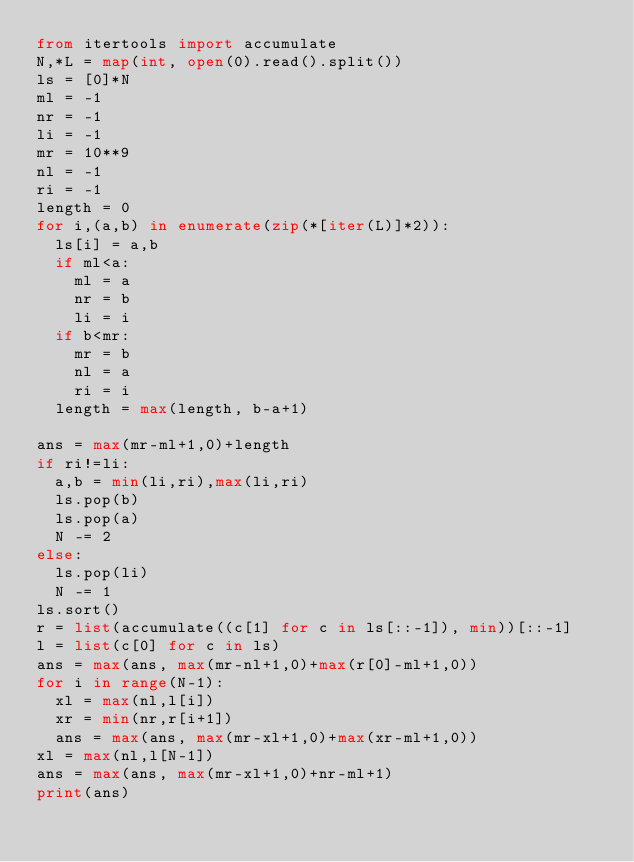Convert code to text. <code><loc_0><loc_0><loc_500><loc_500><_Python_>from itertools import accumulate
N,*L = map(int, open(0).read().split())
ls = [0]*N
ml = -1
nr = -1
li = -1
mr = 10**9
nl = -1
ri = -1
length = 0
for i,(a,b) in enumerate(zip(*[iter(L)]*2)):
  ls[i] = a,b
  if ml<a:
    ml = a
    nr = b
    li = i
  if b<mr:
    mr = b
    nl = a
    ri = i
  length = max(length, b-a+1)

ans = max(mr-ml+1,0)+length
if ri!=li:
  a,b = min(li,ri),max(li,ri)
  ls.pop(b)
  ls.pop(a)
  N -= 2
else:
  ls.pop(li)
  N -= 1
ls.sort()
r = list(accumulate((c[1] for c in ls[::-1]), min))[::-1]
l = list(c[0] for c in ls)
ans = max(ans, max(mr-nl+1,0)+max(r[0]-ml+1,0))
for i in range(N-1):
  xl = max(nl,l[i])
  xr = min(nr,r[i+1])
  ans = max(ans, max(mr-xl+1,0)+max(xr-ml+1,0))
xl = max(nl,l[N-1])
ans = max(ans, max(mr-xl+1,0)+nr-ml+1)
print(ans)</code> 